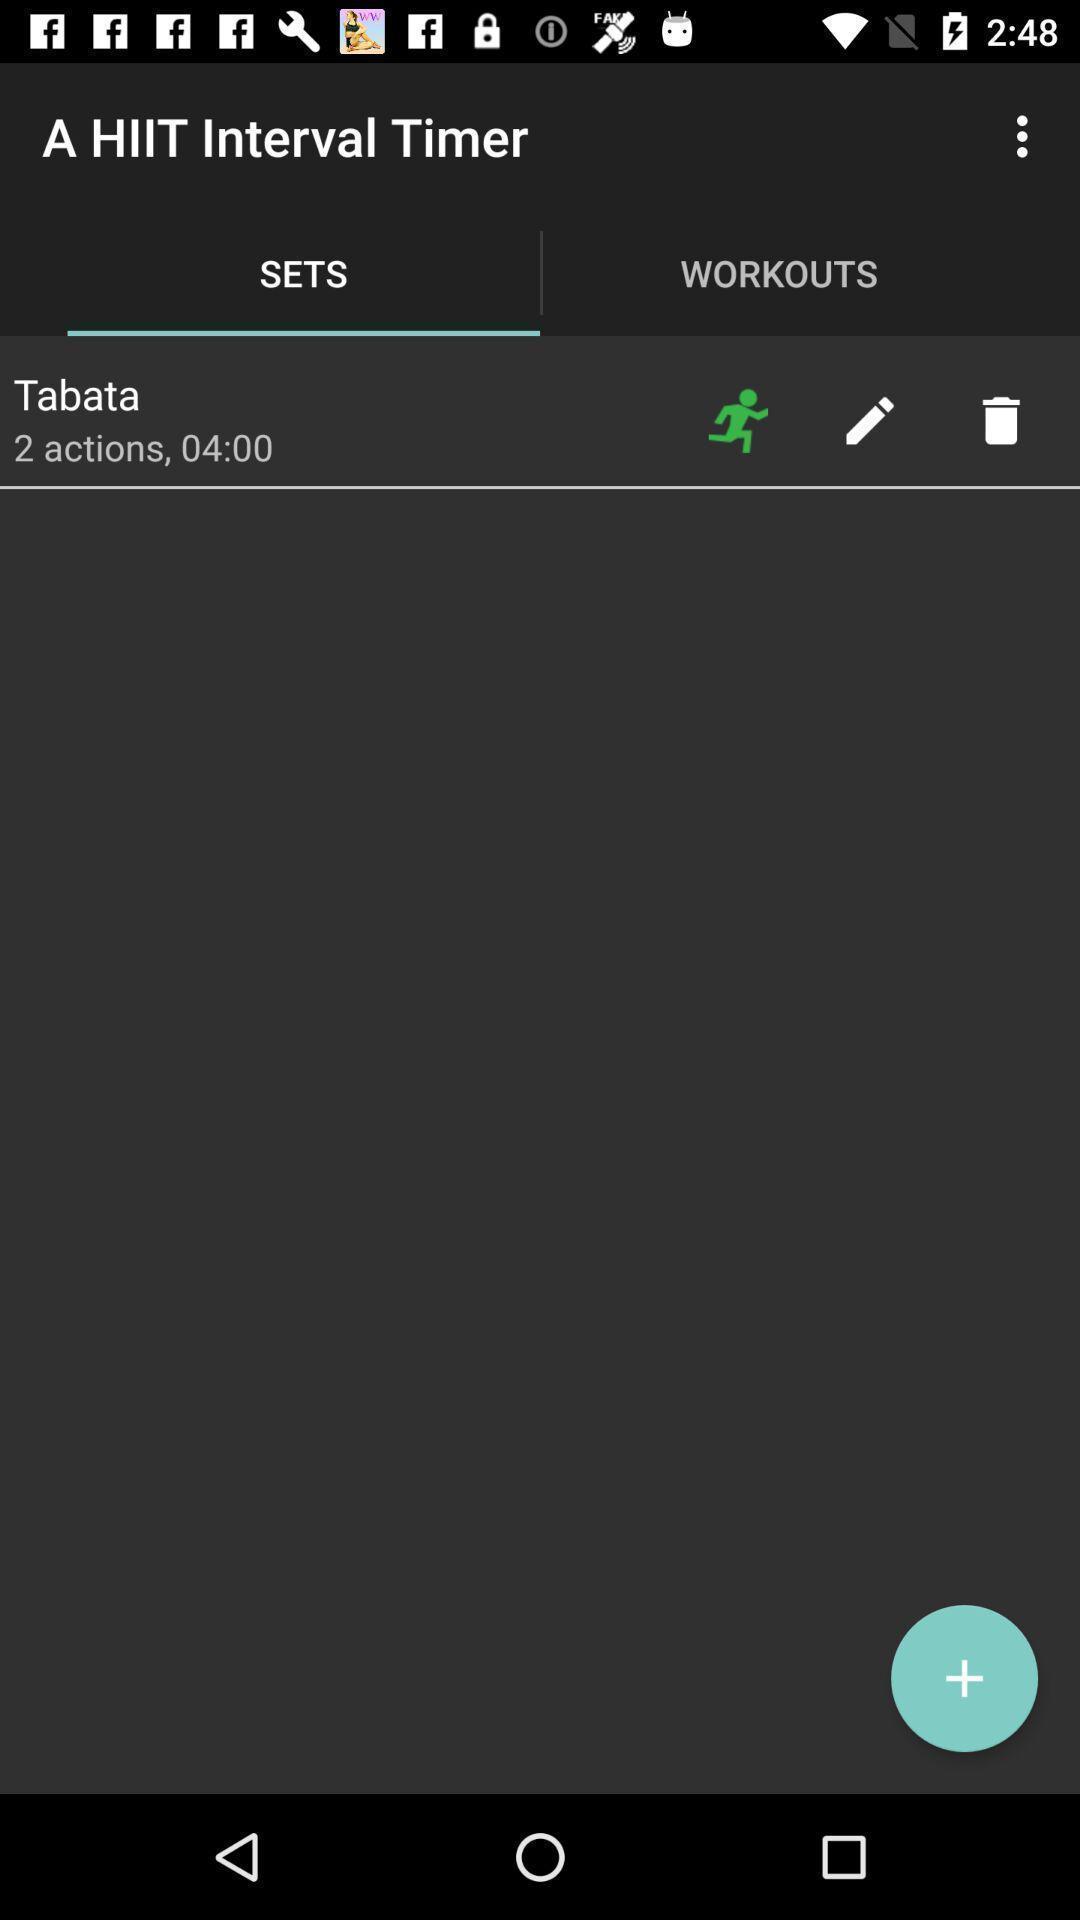Describe this image in words. Page showing timer option in fitness app. 